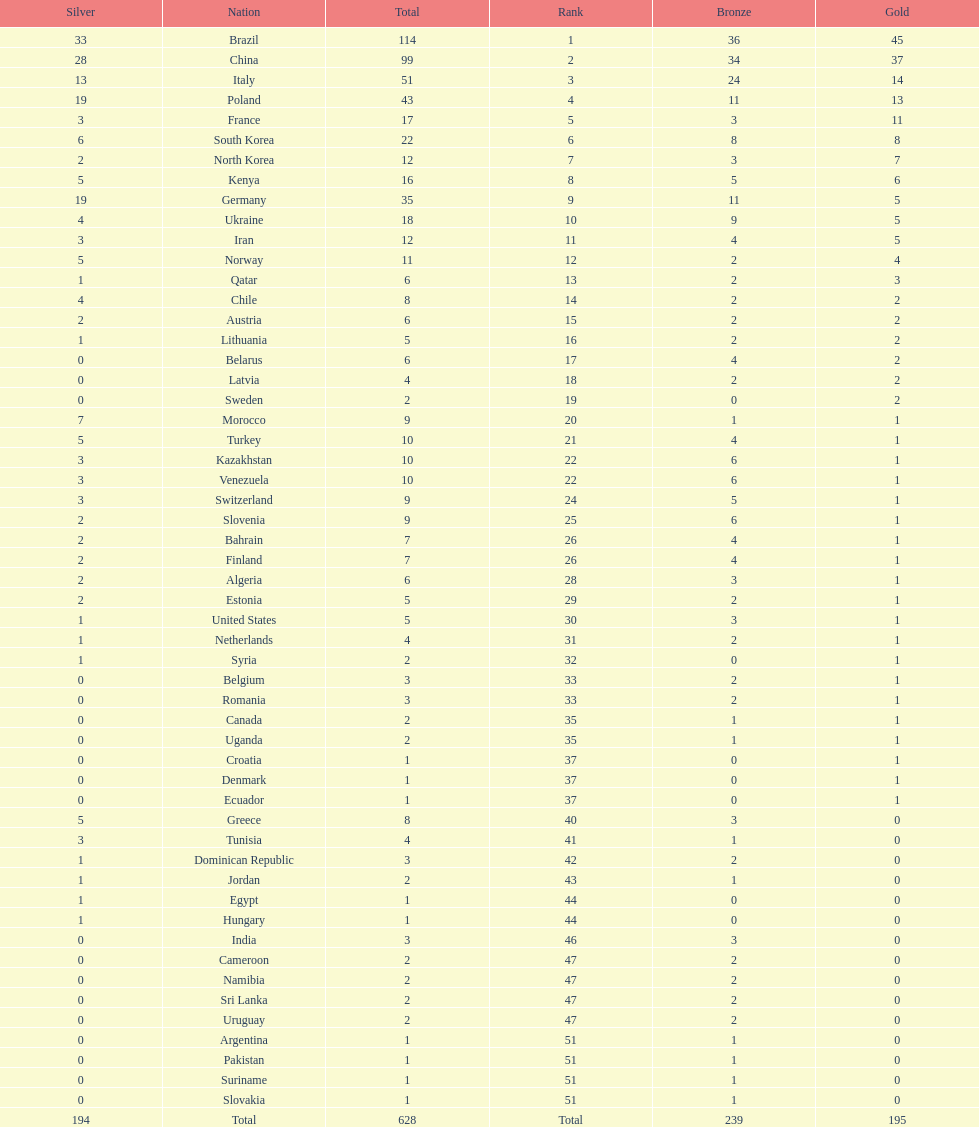Would you be able to parse every entry in this table? {'header': ['Silver', 'Nation', 'Total', 'Rank', 'Bronze', 'Gold'], 'rows': [['33', 'Brazil', '114', '1', '36', '45'], ['28', 'China', '99', '2', '34', '37'], ['13', 'Italy', '51', '3', '24', '14'], ['19', 'Poland', '43', '4', '11', '13'], ['3', 'France', '17', '5', '3', '11'], ['6', 'South Korea', '22', '6', '8', '8'], ['2', 'North Korea', '12', '7', '3', '7'], ['5', 'Kenya', '16', '8', '5', '6'], ['19', 'Germany', '35', '9', '11', '5'], ['4', 'Ukraine', '18', '10', '9', '5'], ['3', 'Iran', '12', '11', '4', '5'], ['5', 'Norway', '11', '12', '2', '4'], ['1', 'Qatar', '6', '13', '2', '3'], ['4', 'Chile', '8', '14', '2', '2'], ['2', 'Austria', '6', '15', '2', '2'], ['1', 'Lithuania', '5', '16', '2', '2'], ['0', 'Belarus', '6', '17', '4', '2'], ['0', 'Latvia', '4', '18', '2', '2'], ['0', 'Sweden', '2', '19', '0', '2'], ['7', 'Morocco', '9', '20', '1', '1'], ['5', 'Turkey', '10', '21', '4', '1'], ['3', 'Kazakhstan', '10', '22', '6', '1'], ['3', 'Venezuela', '10', '22', '6', '1'], ['3', 'Switzerland', '9', '24', '5', '1'], ['2', 'Slovenia', '9', '25', '6', '1'], ['2', 'Bahrain', '7', '26', '4', '1'], ['2', 'Finland', '7', '26', '4', '1'], ['2', 'Algeria', '6', '28', '3', '1'], ['2', 'Estonia', '5', '29', '2', '1'], ['1', 'United States', '5', '30', '3', '1'], ['1', 'Netherlands', '4', '31', '2', '1'], ['1', 'Syria', '2', '32', '0', '1'], ['0', 'Belgium', '3', '33', '2', '1'], ['0', 'Romania', '3', '33', '2', '1'], ['0', 'Canada', '2', '35', '1', '1'], ['0', 'Uganda', '2', '35', '1', '1'], ['0', 'Croatia', '1', '37', '0', '1'], ['0', 'Denmark', '1', '37', '0', '1'], ['0', 'Ecuador', '1', '37', '0', '1'], ['5', 'Greece', '8', '40', '3', '0'], ['3', 'Tunisia', '4', '41', '1', '0'], ['1', 'Dominican Republic', '3', '42', '2', '0'], ['1', 'Jordan', '2', '43', '1', '0'], ['1', 'Egypt', '1', '44', '0', '0'], ['1', 'Hungary', '1', '44', '0', '0'], ['0', 'India', '3', '46', '3', '0'], ['0', 'Cameroon', '2', '47', '2', '0'], ['0', 'Namibia', '2', '47', '2', '0'], ['0', 'Sri Lanka', '2', '47', '2', '0'], ['0', 'Uruguay', '2', '47', '2', '0'], ['0', 'Argentina', '1', '51', '1', '0'], ['0', 'Pakistan', '1', '51', '1', '0'], ['0', 'Suriname', '1', '51', '1', '0'], ['0', 'Slovakia', '1', '51', '1', '0'], ['194', 'Total', '628', 'Total', '239', '195']]} What's the total count of gold medals secured by germany? 5. 